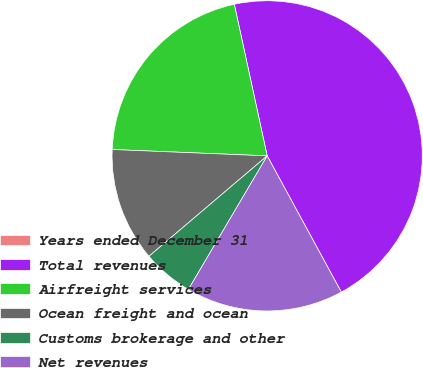Convert chart to OTSL. <chart><loc_0><loc_0><loc_500><loc_500><pie_chart><fcel>Years ended December 31<fcel>Total revenues<fcel>Airfreight services<fcel>Ocean freight and ocean<fcel>Customs brokerage and other<fcel>Net revenues<nl><fcel>0.01%<fcel>45.46%<fcel>20.95%<fcel>11.86%<fcel>5.31%<fcel>16.41%<nl></chart> 